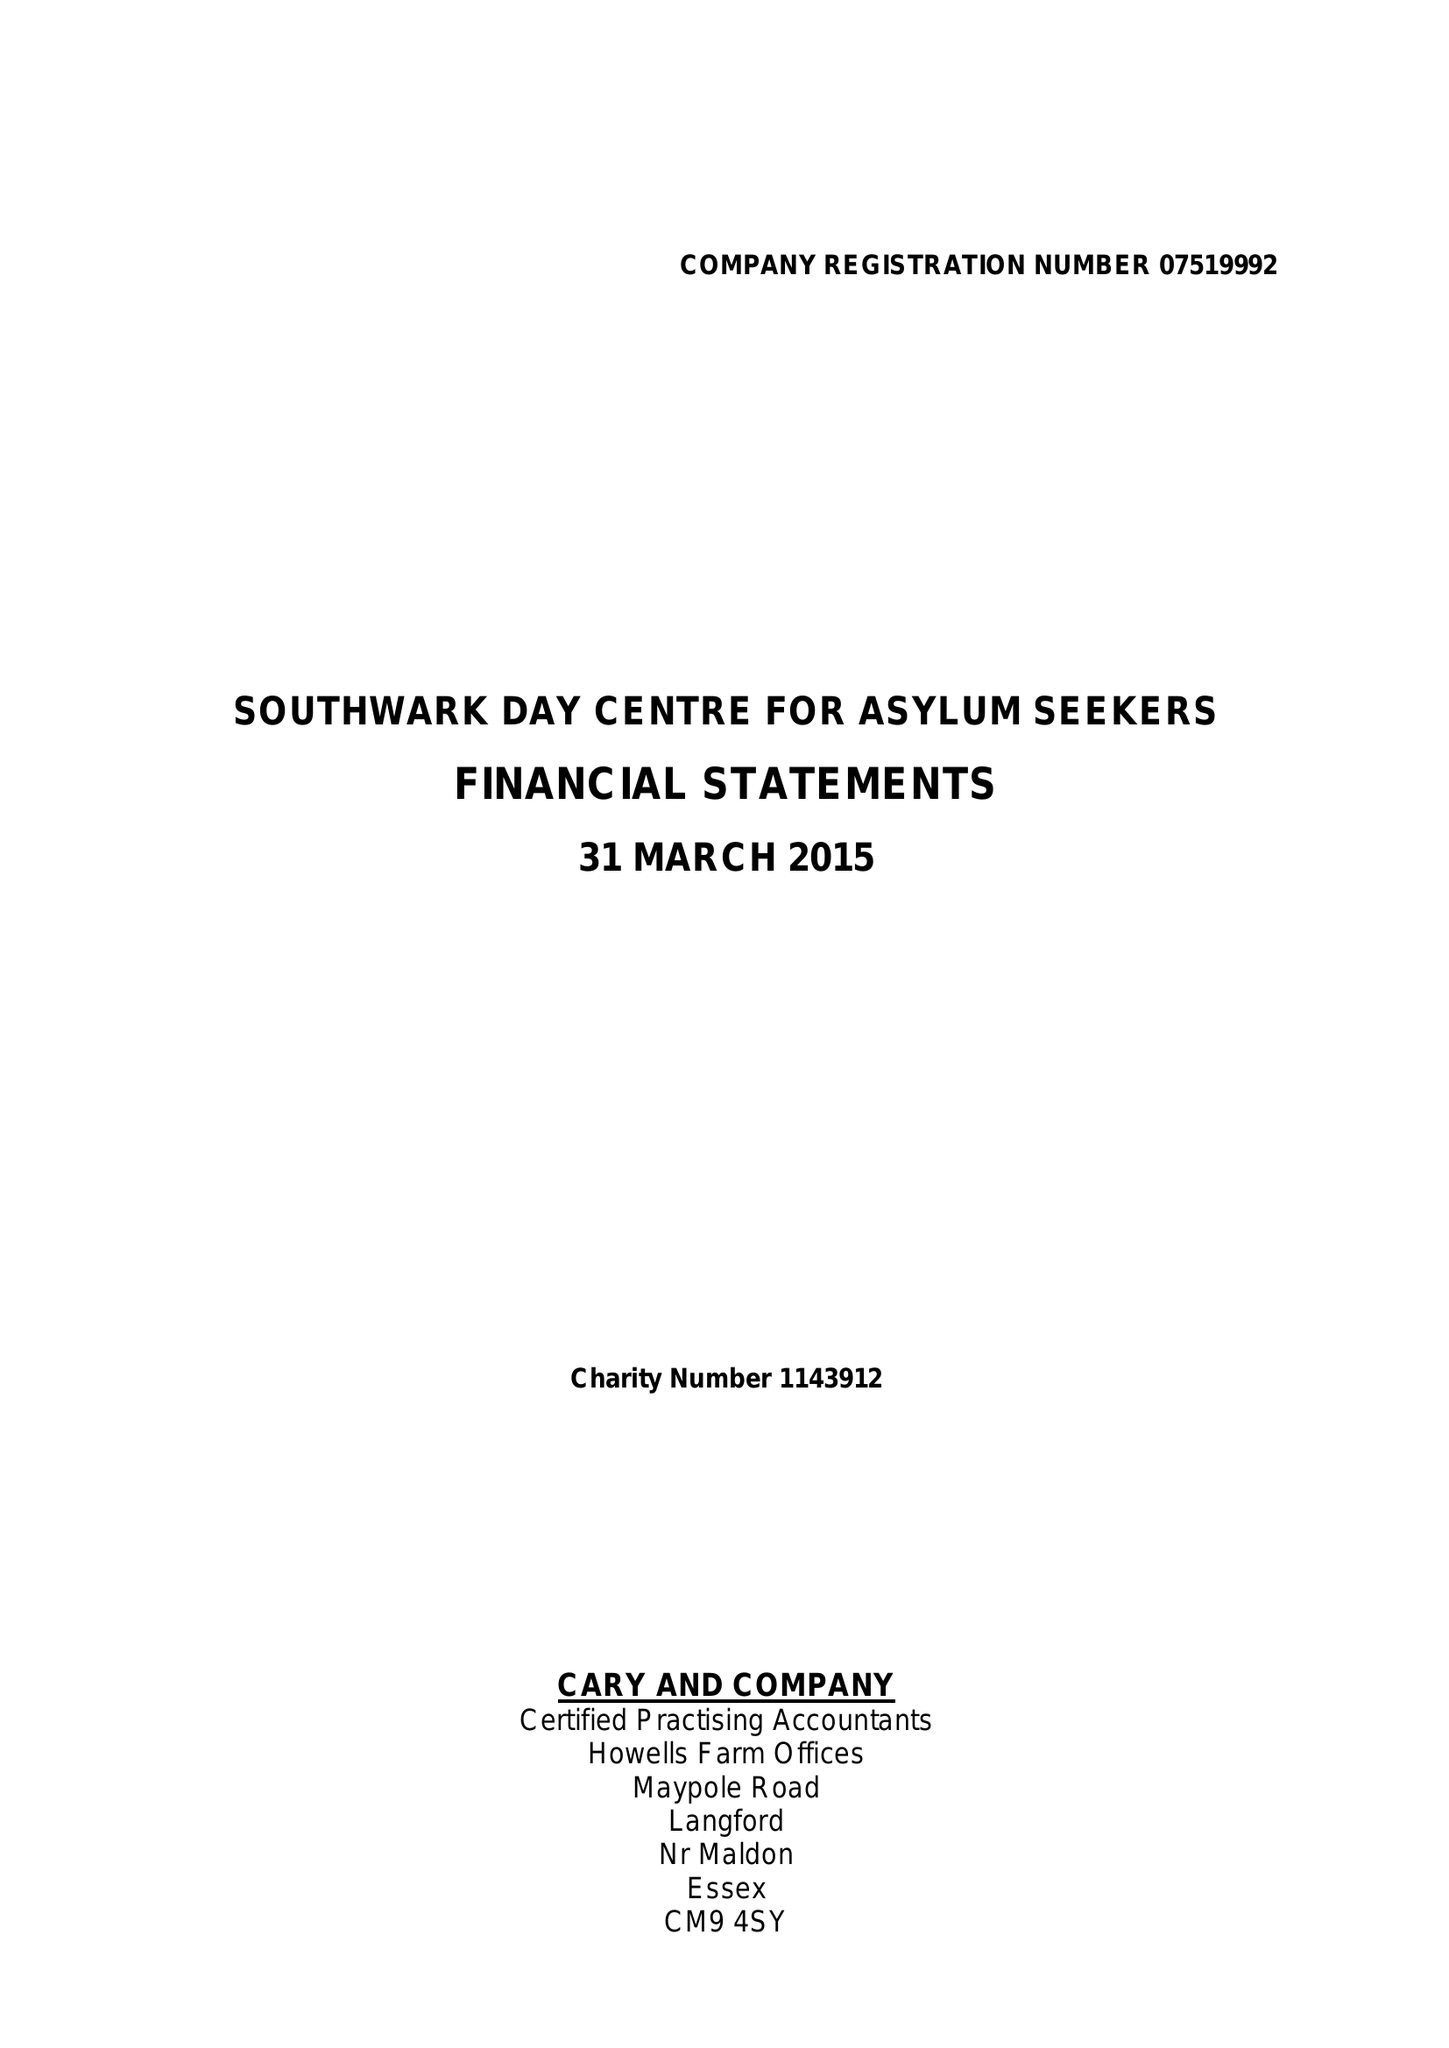What is the value for the charity_number?
Answer the question using a single word or phrase. 1143912 